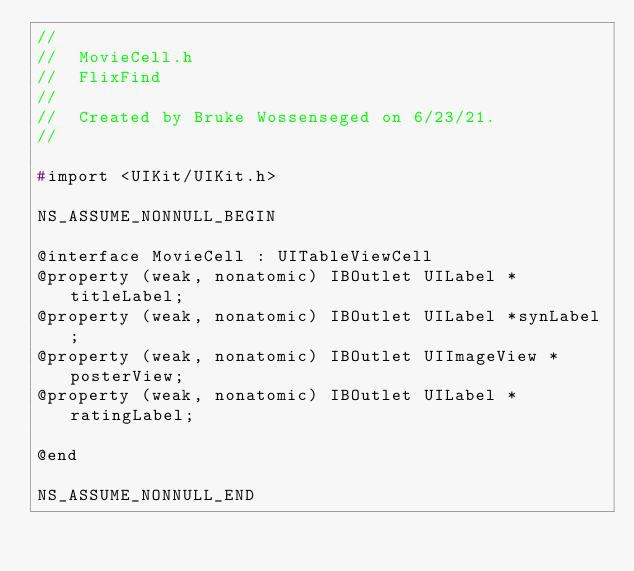<code> <loc_0><loc_0><loc_500><loc_500><_C_>//
//  MovieCell.h
//  FlixFind
//
//  Created by Bruke Wossenseged on 6/23/21.
//

#import <UIKit/UIKit.h>

NS_ASSUME_NONNULL_BEGIN

@interface MovieCell : UITableViewCell
@property (weak, nonatomic) IBOutlet UILabel *titleLabel;
@property (weak, nonatomic) IBOutlet UILabel *synLabel;
@property (weak, nonatomic) IBOutlet UIImageView *posterView;
@property (weak, nonatomic) IBOutlet UILabel *ratingLabel;

@end

NS_ASSUME_NONNULL_END
</code> 